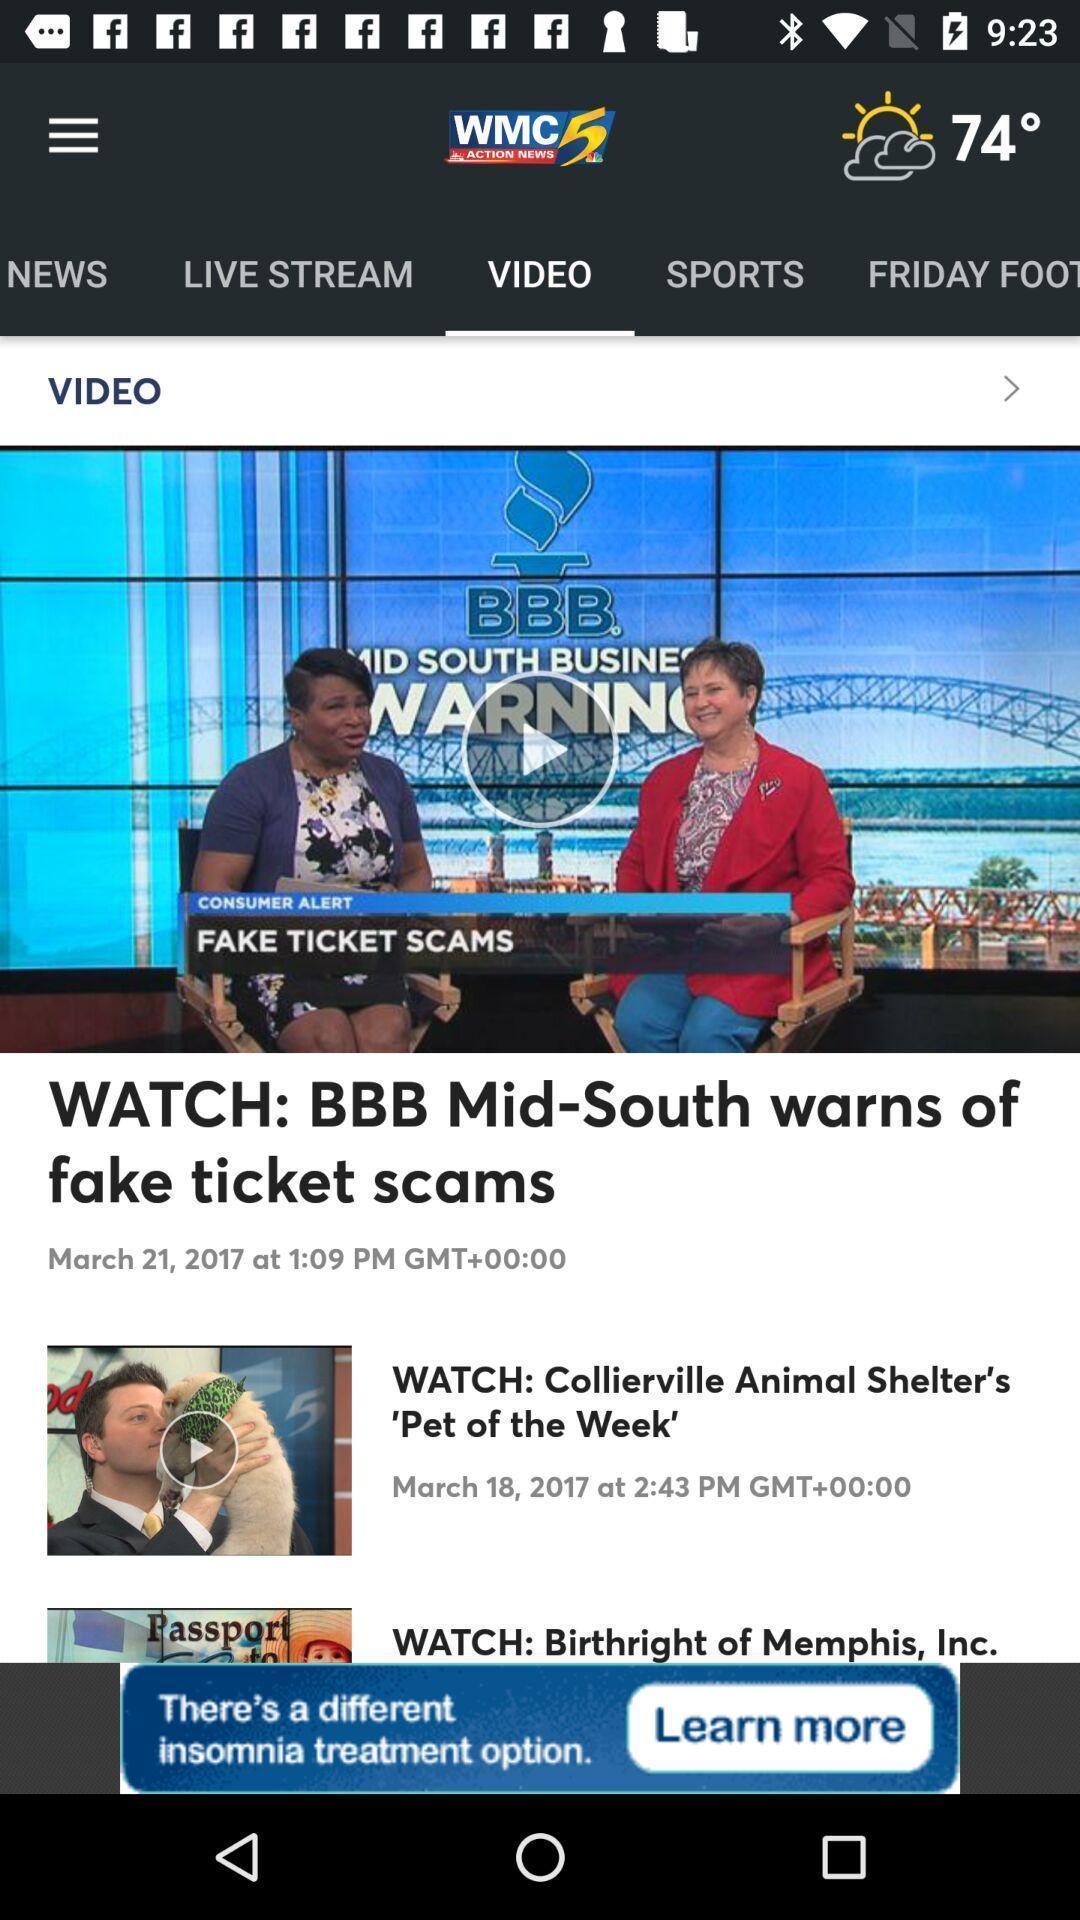Explain the elements present in this screenshot. Videos page of a news app. 